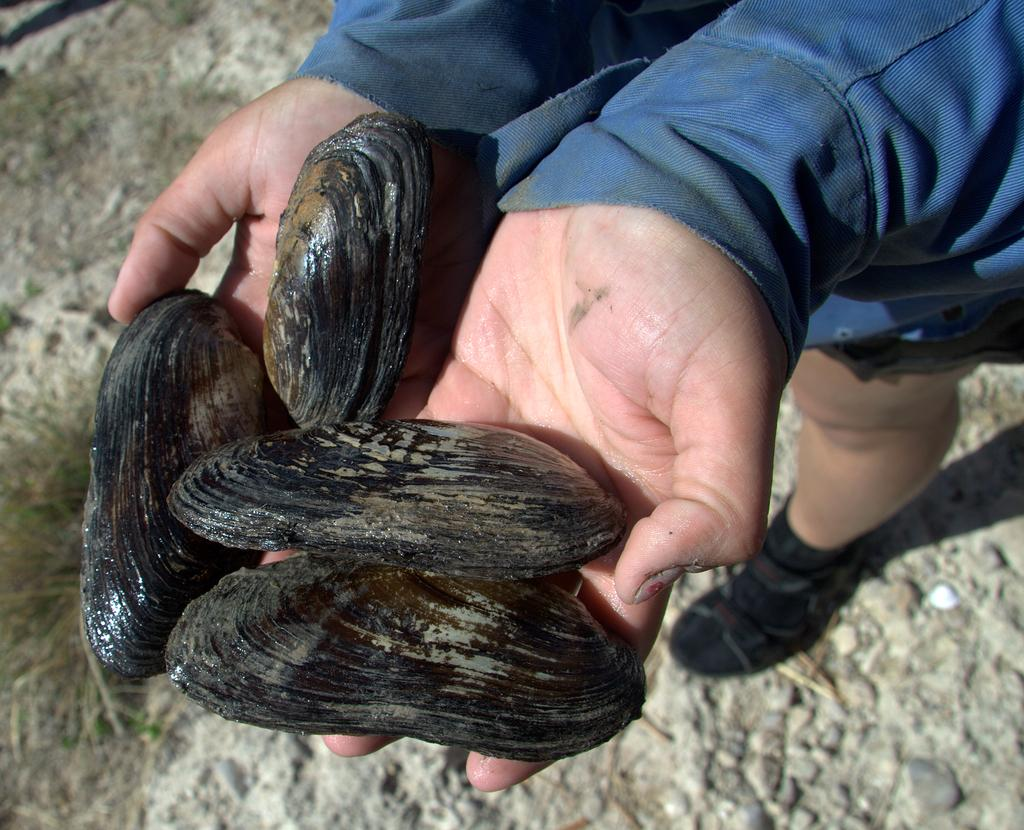What objects are on the hands in the foreground of the image? There are shells on the hands in the foreground of the image. What type of legal advice is the lawyer providing to the cows in the image? There is no lawyer or cows present in the image; it features shells on hands in the foreground. 